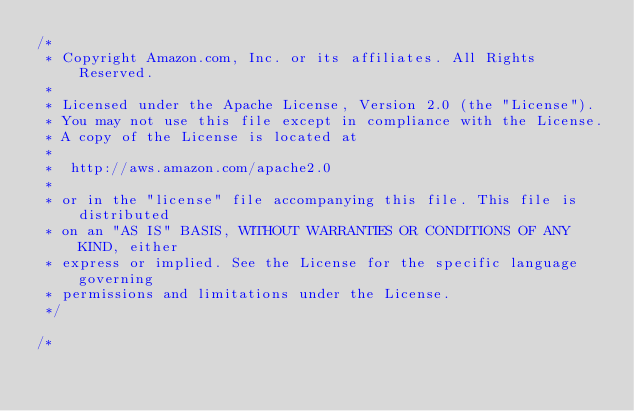<code> <loc_0><loc_0><loc_500><loc_500><_C#_>/*
 * Copyright Amazon.com, Inc. or its affiliates. All Rights Reserved.
 * 
 * Licensed under the Apache License, Version 2.0 (the "License").
 * You may not use this file except in compliance with the License.
 * A copy of the License is located at
 * 
 *  http://aws.amazon.com/apache2.0
 * 
 * or in the "license" file accompanying this file. This file is distributed
 * on an "AS IS" BASIS, WITHOUT WARRANTIES OR CONDITIONS OF ANY KIND, either
 * express or implied. See the License for the specific language governing
 * permissions and limitations under the License.
 */

/*</code> 